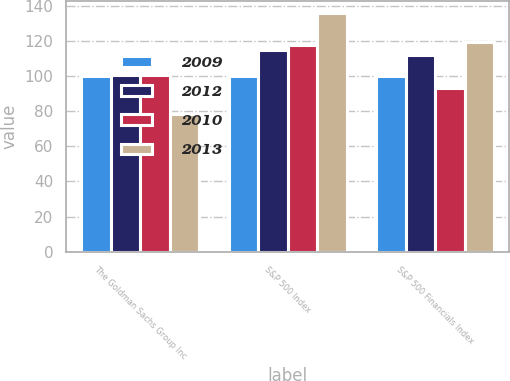<chart> <loc_0><loc_0><loc_500><loc_500><stacked_bar_chart><ecel><fcel>The Goldman Sachs Group Inc<fcel>S&P 500 Index<fcel>S&P 500 Financials Index<nl><fcel>2009<fcel>100<fcel>100<fcel>100<nl><fcel>2012<fcel>100.54<fcel>115.06<fcel>112.13<nl><fcel>2010<fcel>100.54<fcel>117.49<fcel>93<nl><fcel>2013<fcel>78.41<fcel>136.27<fcel>119.73<nl></chart> 